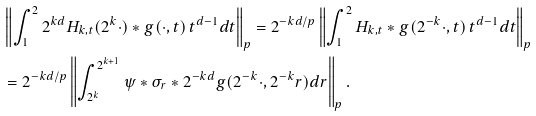Convert formula to latex. <formula><loc_0><loc_0><loc_500><loc_500>& \left \| \int _ { 1 } ^ { 2 } 2 ^ { k d } H _ { k , t } ( 2 ^ { k } \cdot ) * g ( \cdot , t ) \, t ^ { d - 1 } d t \right \| _ { p } = 2 ^ { - k d / p } \left \| \int _ { 1 } ^ { 2 } H _ { k , t } * g ( 2 ^ { - k } \cdot , t ) \, t ^ { d - 1 } d t \right \| _ { p } \\ & = 2 ^ { - k d / p } \left \| \int _ { 2 ^ { k } } ^ { 2 ^ { k + 1 } } \psi * \sigma _ { r } * 2 ^ { - k d } g ( 2 ^ { - k } \cdot , 2 ^ { - k } r ) d r \right \| _ { p } .</formula> 